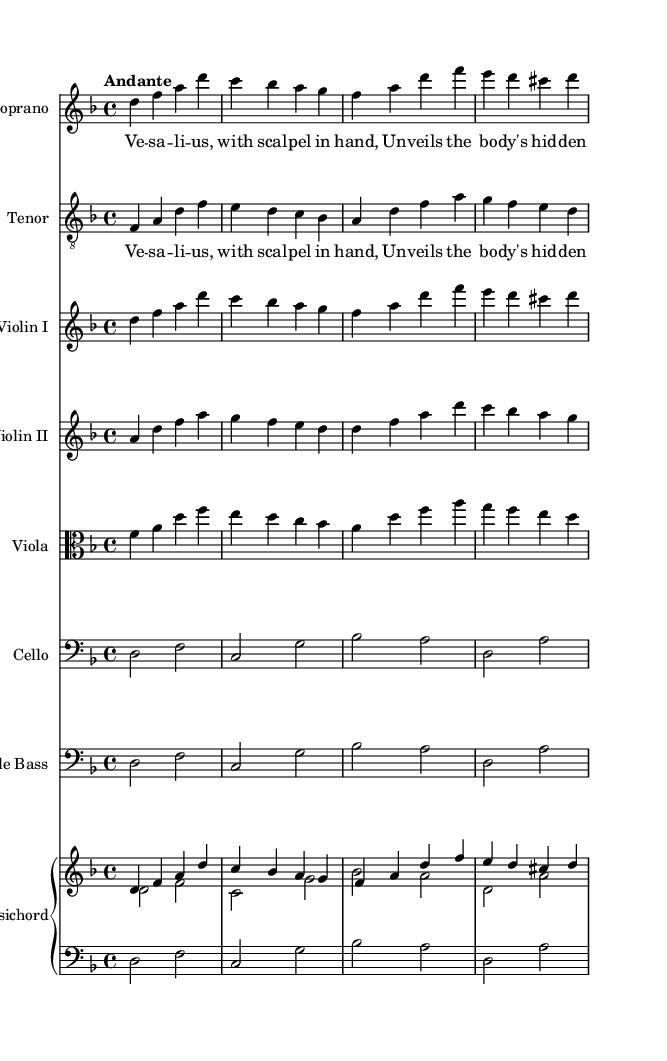What is the key signature of this music? The key signature is indicated at the beginning of the staff and shows two flats (B and E), which corresponds to D minor.
Answer: D minor What is the time signature of this music? The time signature is written at the beginning and is represented by the "4/4" marking, indicating four beats in a measure.
Answer: 4/4 What is the tempo marking for this piece? The tempo marking "Andante" is found at the beginning, which indicates a moderately slow tempo.
Answer: Andante How many voices are present in this excerpt? The music excerpt features two distinct vocal lines, one for soprano and one for tenor, thus indicating two voices.
Answer: Two voices Which historical figure is represented in the lyrics? The lyrics specifically mention "Vesalius," a notable figure in the history of medicine known for his work in anatomy.
Answer: Vesalius What is the primary musical instrumentation used? The score includes a soprano and tenor voice along with string instruments such as violins, viola, cello, and a harpsichord, indicating it is orchestral in nature.
Answer: Orchestral What is the emotional tone conveyed by the phrase “unveils the body's hidden plan”? The phrase suggests an exploration or revelation of unknown knowledge, conveying a tone of discovery and enlightenment related to medical discoveries.
Answer: Discovery 